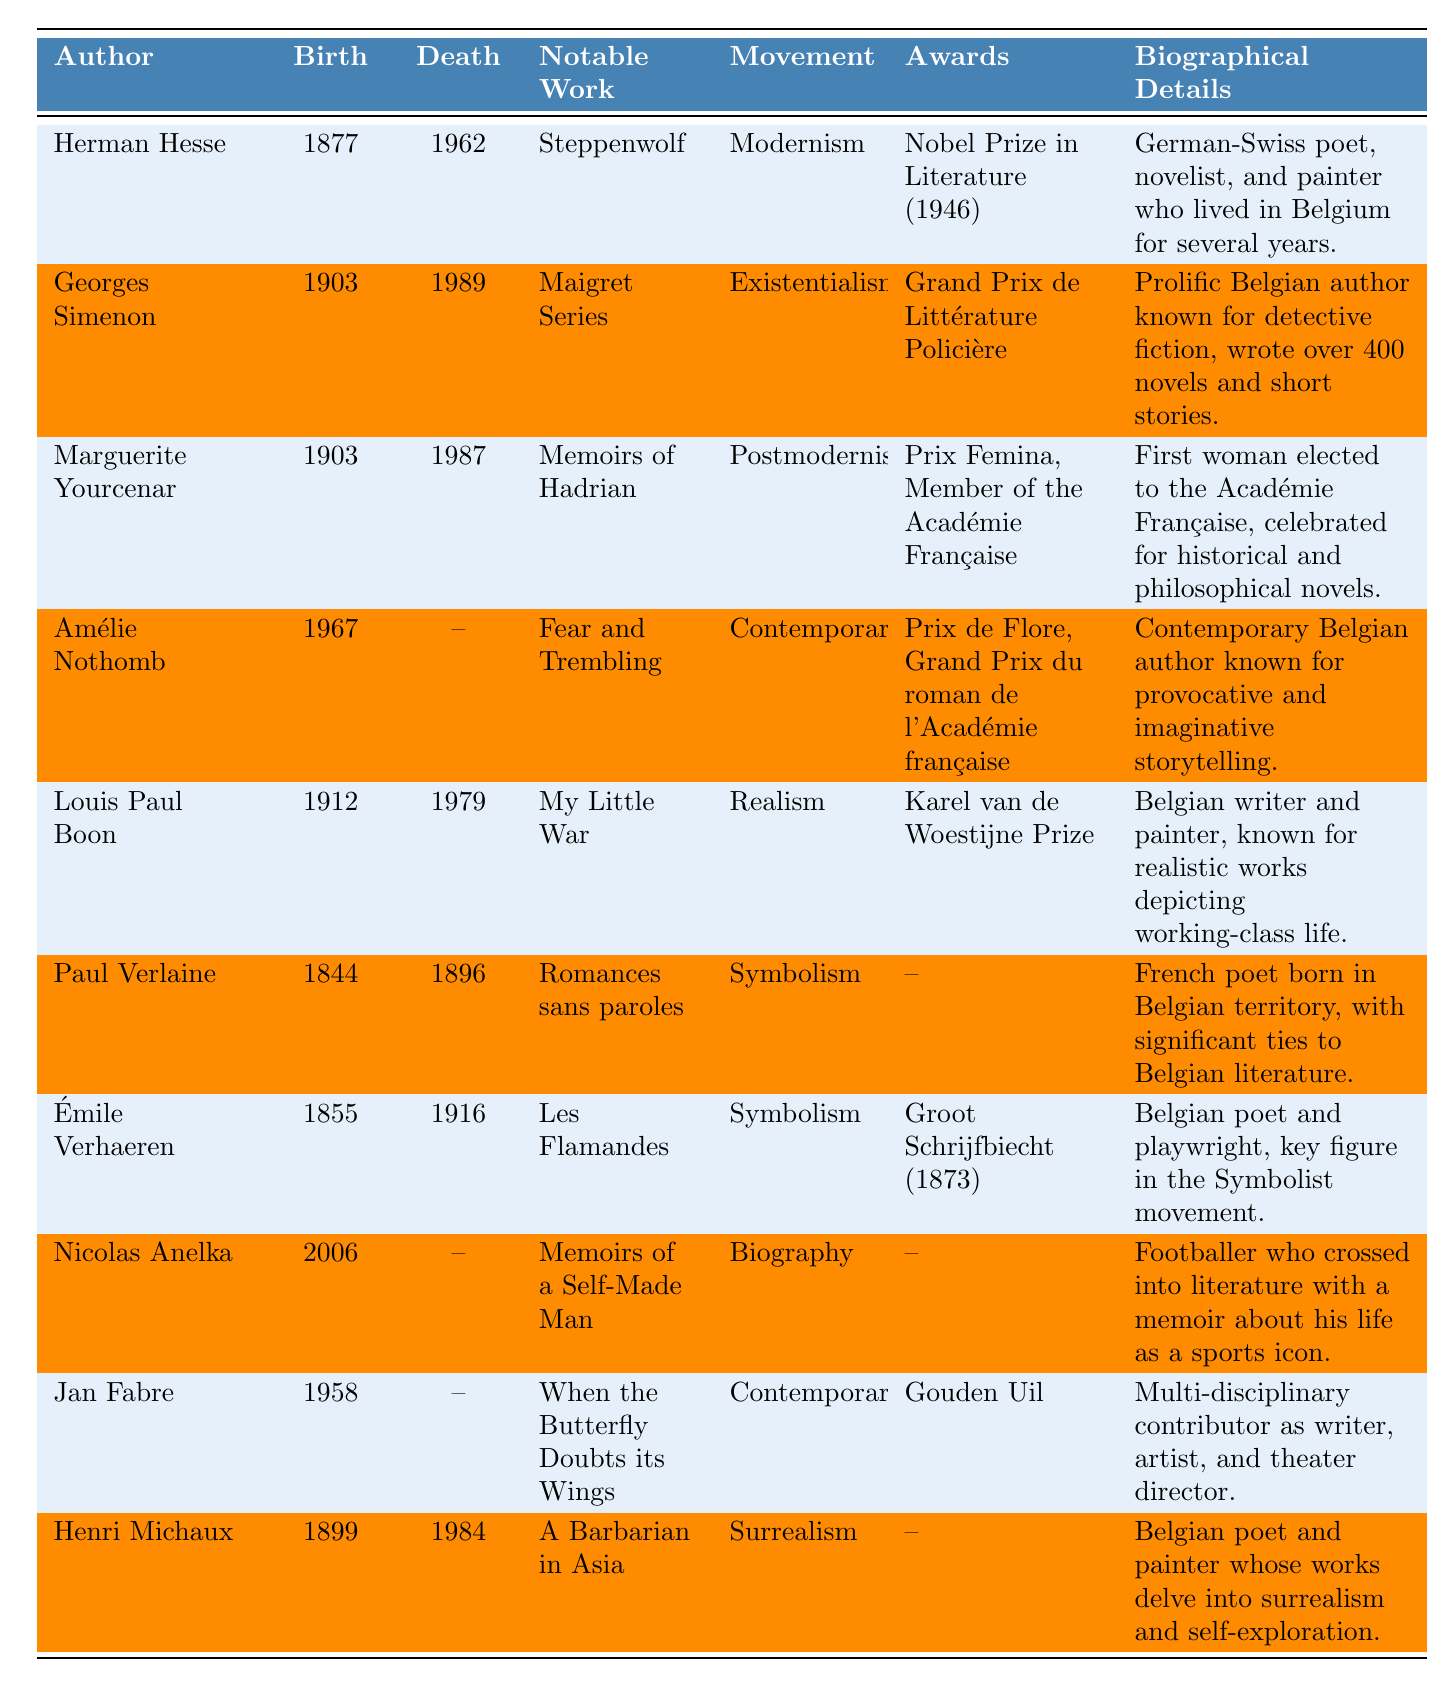What is the notable work of Marguerite Yourcenar? The table lists "Memoirs of Hadrian" as the notable work of Marguerite Yourcenar.
Answer: Memoirs of Hadrian Which authors were born in the 1900s? By checking the birth years, we find Georges Simenon (1903), Marguerite Yourcenar (1903), Louis Paul Boon (1912), and Henri Michaux (1899) were born in the 1900s.
Answer: 4 authors Who received a Nobel Prize in Literature? The table indicates that Herman Hesse is the author who received a Nobel Prize in Literature in 1946.
Answer: Herman Hesse Is Paul Verlaine associated with the Symbolism literary movement? The table confirms that Paul Verlaine is listed under the Symbolism literary movement.
Answer: Yes What is the lifespan of Georges Simenon? Georges Simenon was born in 1903 and died in 1989, so the length of his life is 1989 - 1903 = 86 years.
Answer: 86 years How many authors listed have died before 2000? By examining the death years, we see that Herman Hesse, Georges Simenon, Marguerite Yourcenar, Louis Paul Boon, Paul Verlaine, Émile Verhaeren, and Henri Michaux all died before 2000. This totals to 7 authors.
Answer: 7 authors Which author has the most awards? Marguerite Yourcenar has received the most awards listed (Prix Femina and Member of the Académie Française), totaling 2 awards.
Answer: Marguerite Yourcenar List the literary movements represented by the authors. The literature movements present are Modernism, Existentialism, Postmodernism, Contemporary, Realism, Symbolism, and Surrealism. Therefore, the unique movements are 7 in total.
Answer: 7 movements What notable work corresponds to the author Amélie Nothomb? The table specifies "Fear and Trembling" as the notable work associated with Amélie Nothomb.
Answer: Fear and Trembling Which authors were born after 1950? Amélie Nothomb (1967), Jan Fabre (1958), and Nicolas Anelka (2006) were all born after 1950, giving us 3 authors in total.
Answer: 3 authors 